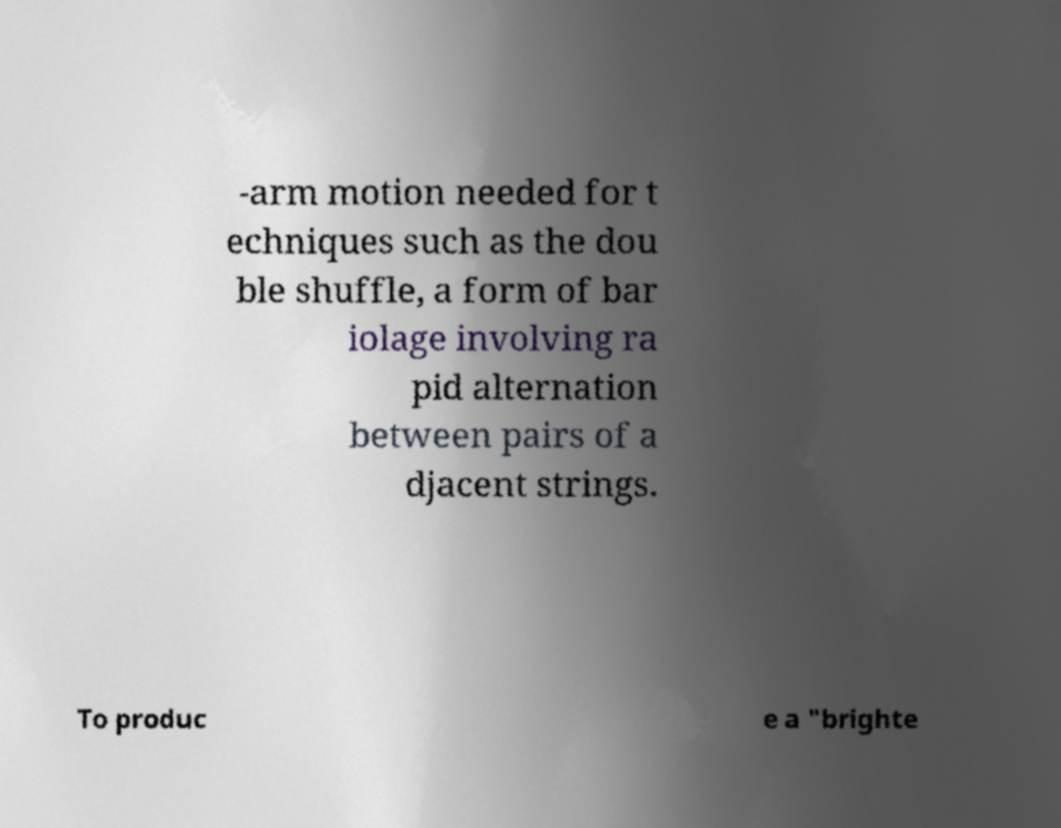Please read and relay the text visible in this image. What does it say? -arm motion needed for t echniques such as the dou ble shuffle, a form of bar iolage involving ra pid alternation between pairs of a djacent strings. To produc e a "brighte 